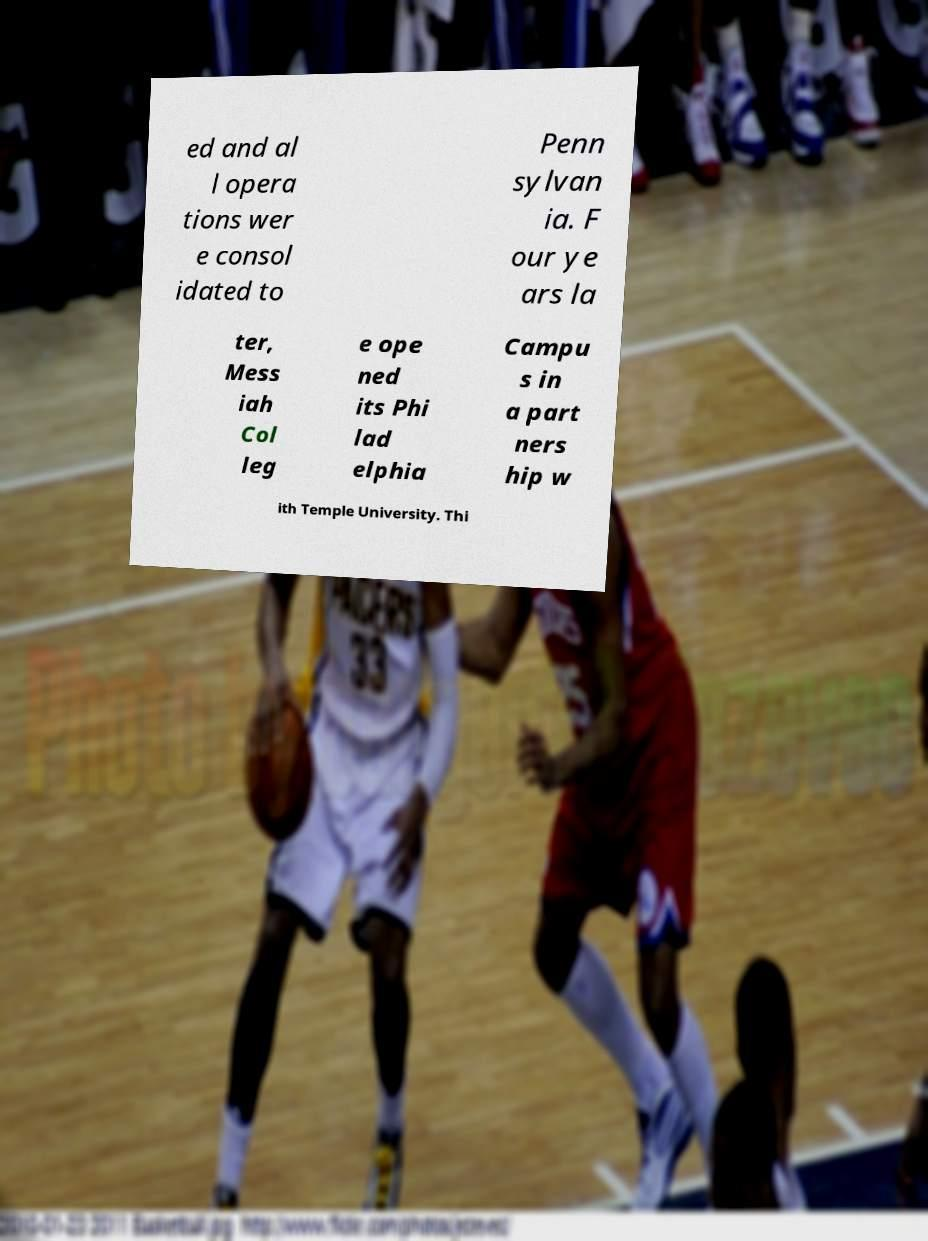Could you extract and type out the text from this image? ed and al l opera tions wer e consol idated to Penn sylvan ia. F our ye ars la ter, Mess iah Col leg e ope ned its Phi lad elphia Campu s in a part ners hip w ith Temple University. Thi 